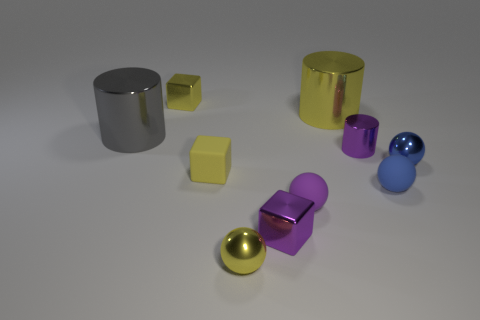There is a yellow metal thing that is the same shape as the small yellow rubber thing; what is its size?
Your answer should be compact. Small. Are there an equal number of small purple metallic cylinders on the left side of the purple metal cube and gray metallic cylinders?
Your answer should be compact. No. There is a large thing that is to the right of the tiny yellow shiny sphere; is its shape the same as the large gray shiny thing?
Your answer should be very brief. Yes. What is the shape of the large gray thing?
Provide a succinct answer. Cylinder. There is a large thing that is on the right side of the yellow shiny object in front of the large metal object behind the gray metal object; what is it made of?
Your response must be concise. Metal. There is another small cube that is the same color as the matte cube; what material is it?
Provide a succinct answer. Metal. What number of objects are either small purple metal objects or big brown metallic objects?
Your answer should be very brief. 2. Is the material of the yellow cube that is behind the purple cylinder the same as the gray cylinder?
Your answer should be very brief. Yes. How many things are either yellow metal blocks that are behind the gray metallic cylinder or yellow blocks?
Provide a succinct answer. 2. What color is the small cylinder that is the same material as the tiny purple block?
Your answer should be compact. Purple. 